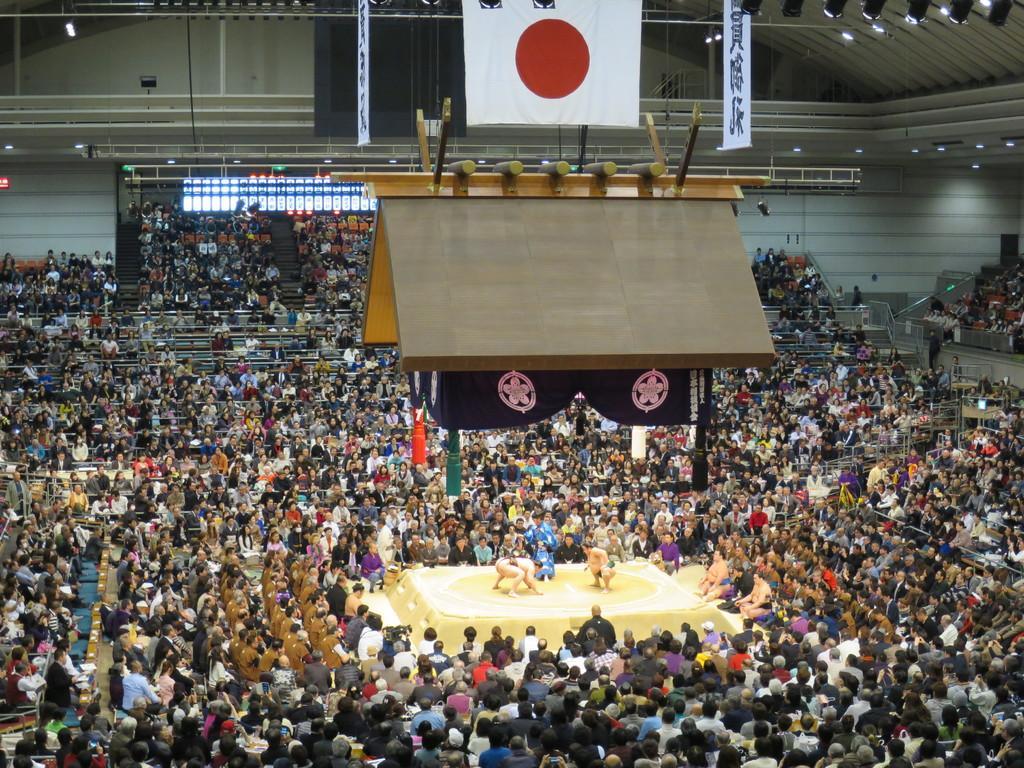Please provide a concise description of this image. In the center of the image we can see two people wrestling and there is crowd sitting. At the top there is a board and a flag. We can see lights. In the background there is a wall. 